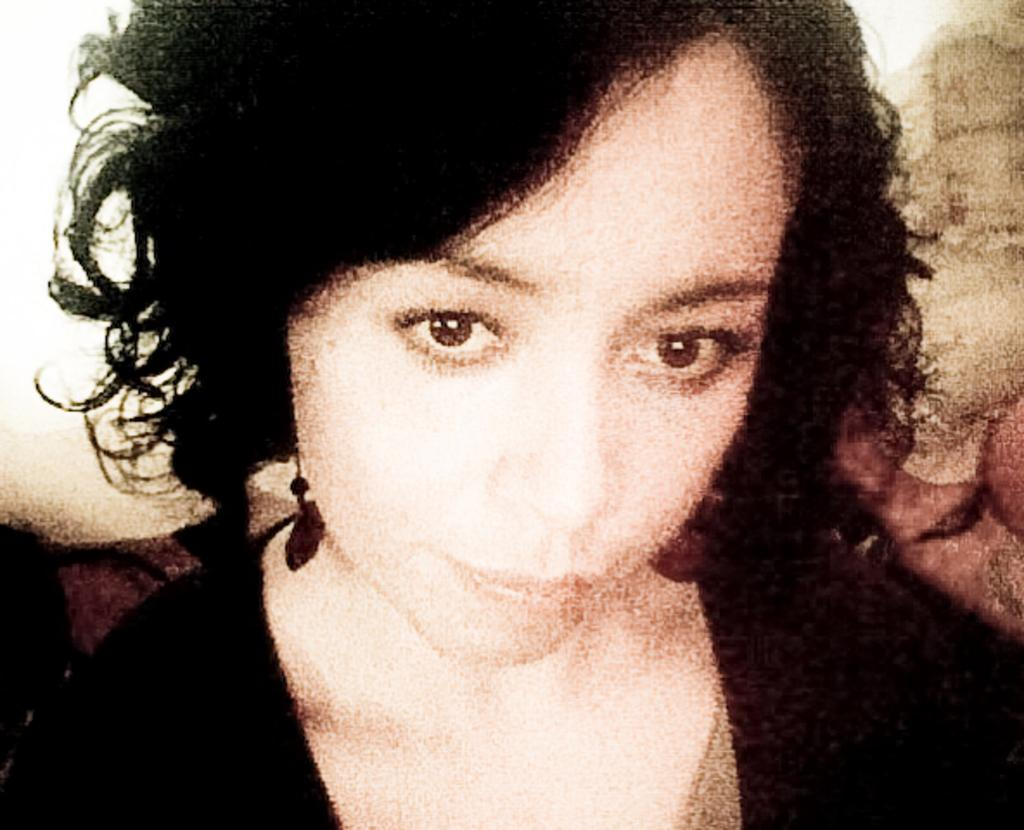Who is present in the image? There is a woman in the image. What is the woman wearing? The woman is wearing a black dress. What type of anger is the woman expressing in the image? There is no indication of anger in the image; the woman is simply present and wearing a black dress. What type of apparatus is the woman using in the image? There is no apparatus present in the image; the woman is simply standing or posing. 